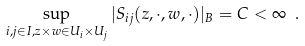Convert formula to latex. <formula><loc_0><loc_0><loc_500><loc_500>\sup _ { i , j \in I , z \times w \in U _ { i } \times U _ { j } } | S _ { i j } ( z , \cdot , w , \cdot ) | _ { B } = C < \infty \ .</formula> 